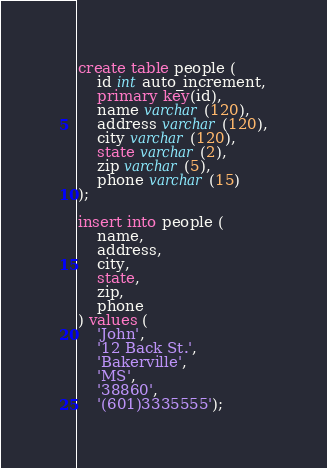<code> <loc_0><loc_0><loc_500><loc_500><_SQL_>

create table people (
    id int auto_increment,
    primary key(id),
    name varchar(120),
    address varchar(120),
    city varchar(120),
    state varchar(2),
    zip varchar(5),
    phone varchar(15)
);

insert into people (
    name, 
    address,
    city,
    state,
    zip,
    phone
) values (
    'John',
    '12 Back St.',
    'Bakerville',
    'MS',
    '38860',
    '(601)3335555');</code> 